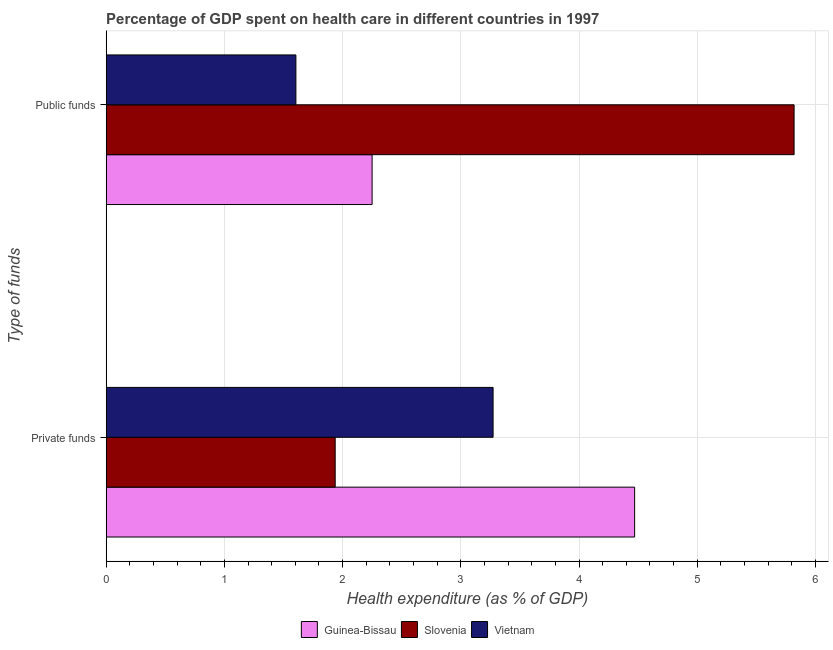Are the number of bars per tick equal to the number of legend labels?
Provide a short and direct response. Yes. How many bars are there on the 1st tick from the top?
Give a very brief answer. 3. How many bars are there on the 1st tick from the bottom?
Give a very brief answer. 3. What is the label of the 1st group of bars from the top?
Give a very brief answer. Public funds. What is the amount of private funds spent in healthcare in Slovenia?
Offer a terse response. 1.94. Across all countries, what is the maximum amount of public funds spent in healthcare?
Offer a very short reply. 5.82. Across all countries, what is the minimum amount of public funds spent in healthcare?
Offer a very short reply. 1.6. In which country was the amount of public funds spent in healthcare maximum?
Your answer should be very brief. Slovenia. In which country was the amount of private funds spent in healthcare minimum?
Give a very brief answer. Slovenia. What is the total amount of private funds spent in healthcare in the graph?
Keep it short and to the point. 9.68. What is the difference between the amount of private funds spent in healthcare in Guinea-Bissau and that in Slovenia?
Your answer should be very brief. 2.53. What is the difference between the amount of public funds spent in healthcare in Guinea-Bissau and the amount of private funds spent in healthcare in Vietnam?
Your response must be concise. -1.02. What is the average amount of private funds spent in healthcare per country?
Your answer should be very brief. 3.23. What is the difference between the amount of public funds spent in healthcare and amount of private funds spent in healthcare in Vietnam?
Your answer should be compact. -1.67. In how many countries, is the amount of public funds spent in healthcare greater than 2 %?
Give a very brief answer. 2. What is the ratio of the amount of private funds spent in healthcare in Vietnam to that in Guinea-Bissau?
Your answer should be compact. 0.73. In how many countries, is the amount of private funds spent in healthcare greater than the average amount of private funds spent in healthcare taken over all countries?
Make the answer very short. 2. What does the 1st bar from the top in Public funds represents?
Ensure brevity in your answer.  Vietnam. What does the 1st bar from the bottom in Public funds represents?
Provide a succinct answer. Guinea-Bissau. How many bars are there?
Your response must be concise. 6. How many countries are there in the graph?
Your response must be concise. 3. Are the values on the major ticks of X-axis written in scientific E-notation?
Offer a very short reply. No. Does the graph contain any zero values?
Provide a succinct answer. No. Does the graph contain grids?
Provide a succinct answer. Yes. How are the legend labels stacked?
Give a very brief answer. Horizontal. What is the title of the graph?
Ensure brevity in your answer.  Percentage of GDP spent on health care in different countries in 1997. Does "Cambodia" appear as one of the legend labels in the graph?
Keep it short and to the point. No. What is the label or title of the X-axis?
Your answer should be very brief. Health expenditure (as % of GDP). What is the label or title of the Y-axis?
Offer a very short reply. Type of funds. What is the Health expenditure (as % of GDP) of Guinea-Bissau in Private funds?
Your answer should be compact. 4.47. What is the Health expenditure (as % of GDP) of Slovenia in Private funds?
Your response must be concise. 1.94. What is the Health expenditure (as % of GDP) of Vietnam in Private funds?
Your answer should be compact. 3.27. What is the Health expenditure (as % of GDP) in Guinea-Bissau in Public funds?
Your answer should be compact. 2.25. What is the Health expenditure (as % of GDP) in Slovenia in Public funds?
Offer a terse response. 5.82. What is the Health expenditure (as % of GDP) of Vietnam in Public funds?
Make the answer very short. 1.6. Across all Type of funds, what is the maximum Health expenditure (as % of GDP) of Guinea-Bissau?
Make the answer very short. 4.47. Across all Type of funds, what is the maximum Health expenditure (as % of GDP) in Slovenia?
Your response must be concise. 5.82. Across all Type of funds, what is the maximum Health expenditure (as % of GDP) of Vietnam?
Offer a very short reply. 3.27. Across all Type of funds, what is the minimum Health expenditure (as % of GDP) of Guinea-Bissau?
Make the answer very short. 2.25. Across all Type of funds, what is the minimum Health expenditure (as % of GDP) in Slovenia?
Give a very brief answer. 1.94. Across all Type of funds, what is the minimum Health expenditure (as % of GDP) in Vietnam?
Keep it short and to the point. 1.6. What is the total Health expenditure (as % of GDP) in Guinea-Bissau in the graph?
Provide a short and direct response. 6.72. What is the total Health expenditure (as % of GDP) of Slovenia in the graph?
Ensure brevity in your answer.  7.76. What is the total Health expenditure (as % of GDP) of Vietnam in the graph?
Ensure brevity in your answer.  4.88. What is the difference between the Health expenditure (as % of GDP) in Guinea-Bissau in Private funds and that in Public funds?
Give a very brief answer. 2.22. What is the difference between the Health expenditure (as % of GDP) of Slovenia in Private funds and that in Public funds?
Provide a short and direct response. -3.88. What is the difference between the Health expenditure (as % of GDP) in Vietnam in Private funds and that in Public funds?
Offer a very short reply. 1.67. What is the difference between the Health expenditure (as % of GDP) of Guinea-Bissau in Private funds and the Health expenditure (as % of GDP) of Slovenia in Public funds?
Provide a short and direct response. -1.35. What is the difference between the Health expenditure (as % of GDP) in Guinea-Bissau in Private funds and the Health expenditure (as % of GDP) in Vietnam in Public funds?
Provide a short and direct response. 2.87. What is the difference between the Health expenditure (as % of GDP) of Slovenia in Private funds and the Health expenditure (as % of GDP) of Vietnam in Public funds?
Offer a very short reply. 0.33. What is the average Health expenditure (as % of GDP) of Guinea-Bissau per Type of funds?
Provide a succinct answer. 3.36. What is the average Health expenditure (as % of GDP) in Slovenia per Type of funds?
Make the answer very short. 3.88. What is the average Health expenditure (as % of GDP) in Vietnam per Type of funds?
Offer a terse response. 2.44. What is the difference between the Health expenditure (as % of GDP) of Guinea-Bissau and Health expenditure (as % of GDP) of Slovenia in Private funds?
Offer a terse response. 2.53. What is the difference between the Health expenditure (as % of GDP) in Guinea-Bissau and Health expenditure (as % of GDP) in Vietnam in Private funds?
Offer a terse response. 1.2. What is the difference between the Health expenditure (as % of GDP) of Slovenia and Health expenditure (as % of GDP) of Vietnam in Private funds?
Your answer should be very brief. -1.34. What is the difference between the Health expenditure (as % of GDP) of Guinea-Bissau and Health expenditure (as % of GDP) of Slovenia in Public funds?
Your answer should be compact. -3.57. What is the difference between the Health expenditure (as % of GDP) in Guinea-Bissau and Health expenditure (as % of GDP) in Vietnam in Public funds?
Your response must be concise. 0.64. What is the difference between the Health expenditure (as % of GDP) in Slovenia and Health expenditure (as % of GDP) in Vietnam in Public funds?
Your response must be concise. 4.21. What is the ratio of the Health expenditure (as % of GDP) of Guinea-Bissau in Private funds to that in Public funds?
Provide a short and direct response. 1.99. What is the ratio of the Health expenditure (as % of GDP) of Slovenia in Private funds to that in Public funds?
Ensure brevity in your answer.  0.33. What is the ratio of the Health expenditure (as % of GDP) of Vietnam in Private funds to that in Public funds?
Give a very brief answer. 2.04. What is the difference between the highest and the second highest Health expenditure (as % of GDP) of Guinea-Bissau?
Your answer should be compact. 2.22. What is the difference between the highest and the second highest Health expenditure (as % of GDP) in Slovenia?
Give a very brief answer. 3.88. What is the difference between the highest and the second highest Health expenditure (as % of GDP) in Vietnam?
Your answer should be very brief. 1.67. What is the difference between the highest and the lowest Health expenditure (as % of GDP) in Guinea-Bissau?
Keep it short and to the point. 2.22. What is the difference between the highest and the lowest Health expenditure (as % of GDP) of Slovenia?
Give a very brief answer. 3.88. What is the difference between the highest and the lowest Health expenditure (as % of GDP) of Vietnam?
Provide a short and direct response. 1.67. 